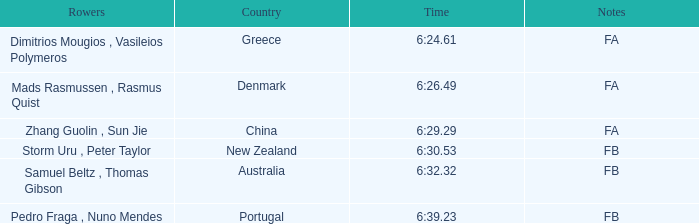What country has a rank smaller than 6, a time of 6:32.32 and notes of FB? Australia. 